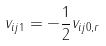<formula> <loc_0><loc_0><loc_500><loc_500>v _ { i j 1 } = - \frac { 1 } { 2 } v _ { i j 0 , r }</formula> 